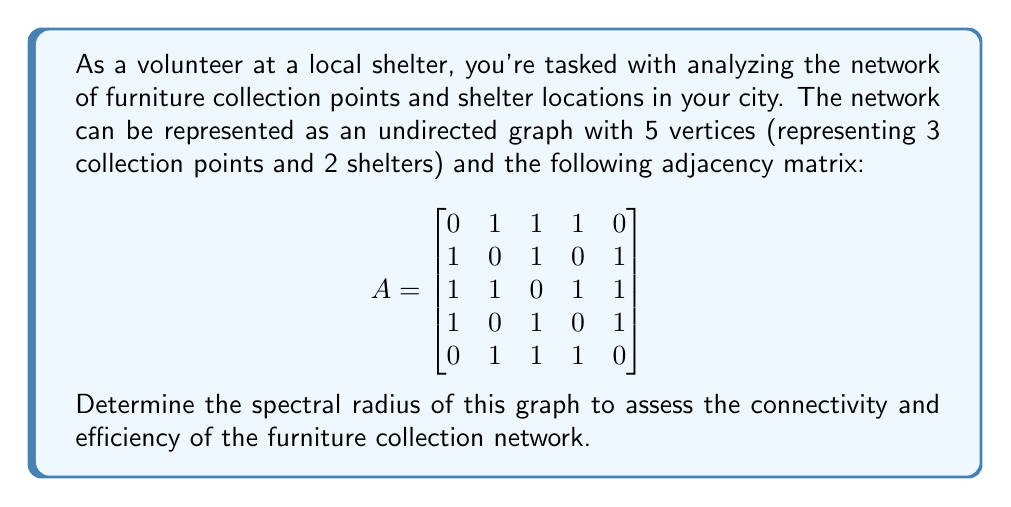Can you answer this question? To find the spectral radius of the graph, we need to follow these steps:

1) The spectral radius is the largest absolute value of the eigenvalues of the adjacency matrix A.

2) To find the eigenvalues, we need to solve the characteristic equation:
   $\det(A - \lambda I) = 0$, where I is the 5x5 identity matrix.

3) Expanding this determinant:
   $$\det\begin{bmatrix}
   -\lambda & 1 & 1 & 1 & 0 \\
   1 & -\lambda & 1 & 0 & 1 \\
   1 & 1 & -\lambda & 1 & 1 \\
   1 & 0 & 1 & -\lambda & 1 \\
   0 & 1 & 1 & 1 & -\lambda
   \end{bmatrix} = 0$$

4) This expands to the characteristic polynomial:
   $\lambda^5 - 8\lambda^3 - 8\lambda^2 + 12\lambda + 4 = 0$

5) While we can't solve this exactly by hand, we can use numerical methods or computer algebra systems to find the roots.

6) The roots (eigenvalues) are approximately:
   $\lambda_1 \approx 2.7322$
   $\lambda_2 \approx 1.1402$
   $\lambda_3 \approx -1.4340$
   $\lambda_4 \approx -1.4340$
   $\lambda_5 \approx -1.0044$

7) The spectral radius is the largest absolute value among these eigenvalues, which is $|\lambda_1| \approx 2.7322$.
Answer: $2.7322$ 